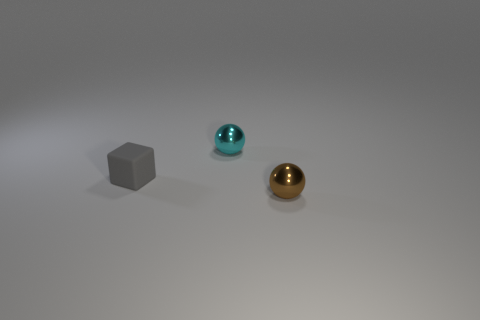If these objects were part of a visual art piece, what might it represent? These objects might represent the theme of diversity and uniformity. The variation in colors, textures, and the consistent shape of spheres could symbolize the idea that despite differences in appearance, there can be underlying unity. Could you speculate on the materials these objects might be made of? Based on their appearance, the cube could be made of a matte metal or plastic, the cyan sphere could be a polished metal or glass, and the gold sphere appears to be a reflective metal, suggesting a polished brass or gold plating. 